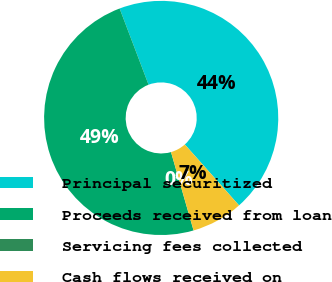Convert chart. <chart><loc_0><loc_0><loc_500><loc_500><pie_chart><fcel>Principal securitized<fcel>Proceeds received from loan<fcel>Servicing fees collected<fcel>Cash flows received on<nl><fcel>44.2%<fcel>48.68%<fcel>0.01%<fcel>7.11%<nl></chart> 